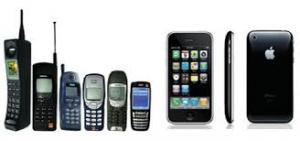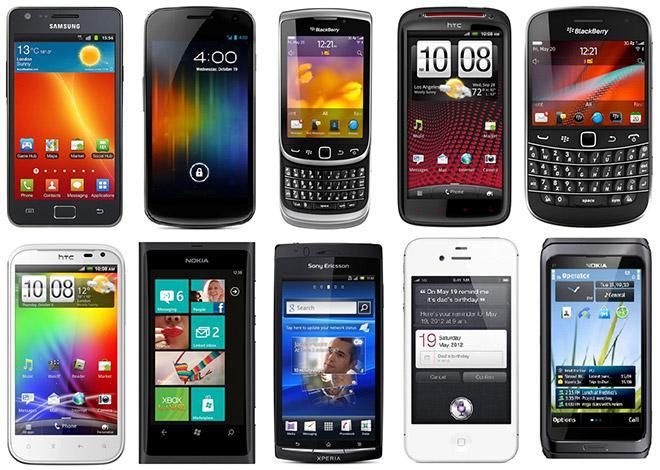The first image is the image on the left, the second image is the image on the right. Considering the images on both sides, is "A cell phone opens horizontally in the image on the right." valid? Answer yes or no. No. The first image is the image on the left, the second image is the image on the right. For the images displayed, is the sentence "The left image contains no more than two cell phones." factually correct? Answer yes or no. No. 